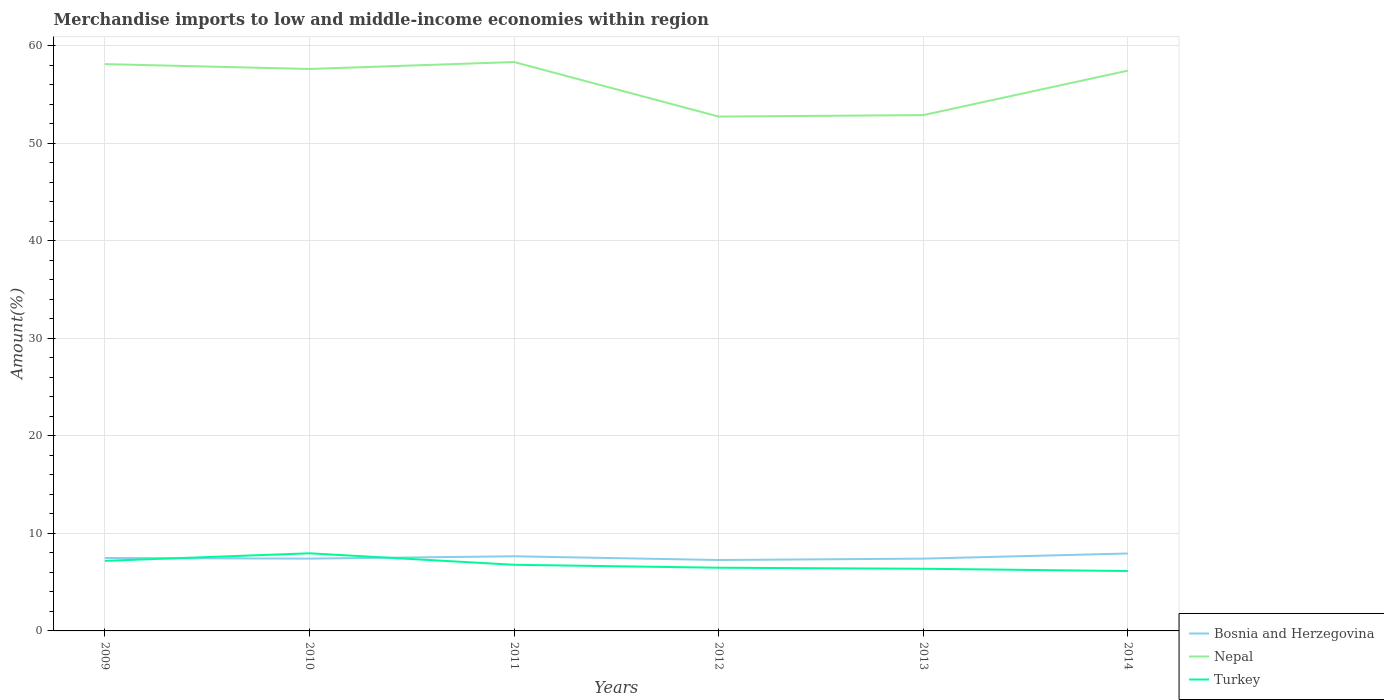How many different coloured lines are there?
Offer a terse response. 3. Is the number of lines equal to the number of legend labels?
Make the answer very short. Yes. Across all years, what is the maximum percentage of amount earned from merchandise imports in Turkey?
Provide a short and direct response. 6.14. What is the total percentage of amount earned from merchandise imports in Bosnia and Herzegovina in the graph?
Your answer should be very brief. -0.53. What is the difference between the highest and the second highest percentage of amount earned from merchandise imports in Turkey?
Your answer should be very brief. 1.82. Is the percentage of amount earned from merchandise imports in Bosnia and Herzegovina strictly greater than the percentage of amount earned from merchandise imports in Turkey over the years?
Provide a short and direct response. No. What is the difference between two consecutive major ticks on the Y-axis?
Your answer should be very brief. 10. Are the values on the major ticks of Y-axis written in scientific E-notation?
Your answer should be compact. No. Does the graph contain any zero values?
Your answer should be very brief. No. Does the graph contain grids?
Your answer should be compact. Yes. How are the legend labels stacked?
Provide a succinct answer. Vertical. What is the title of the graph?
Make the answer very short. Merchandise imports to low and middle-income economies within region. Does "Low & middle income" appear as one of the legend labels in the graph?
Ensure brevity in your answer.  No. What is the label or title of the Y-axis?
Offer a very short reply. Amount(%). What is the Amount(%) in Bosnia and Herzegovina in 2009?
Ensure brevity in your answer.  7.48. What is the Amount(%) of Nepal in 2009?
Ensure brevity in your answer.  58.12. What is the Amount(%) of Turkey in 2009?
Provide a succinct answer. 7.19. What is the Amount(%) of Bosnia and Herzegovina in 2010?
Give a very brief answer. 7.41. What is the Amount(%) in Nepal in 2010?
Keep it short and to the point. 57.62. What is the Amount(%) in Turkey in 2010?
Keep it short and to the point. 7.96. What is the Amount(%) in Bosnia and Herzegovina in 2011?
Give a very brief answer. 7.65. What is the Amount(%) of Nepal in 2011?
Your answer should be compact. 58.33. What is the Amount(%) in Turkey in 2011?
Ensure brevity in your answer.  6.78. What is the Amount(%) of Bosnia and Herzegovina in 2012?
Your response must be concise. 7.27. What is the Amount(%) in Nepal in 2012?
Keep it short and to the point. 52.74. What is the Amount(%) of Turkey in 2012?
Offer a very short reply. 6.48. What is the Amount(%) in Bosnia and Herzegovina in 2013?
Your answer should be compact. 7.41. What is the Amount(%) of Nepal in 2013?
Provide a succinct answer. 52.89. What is the Amount(%) of Turkey in 2013?
Provide a succinct answer. 6.37. What is the Amount(%) in Bosnia and Herzegovina in 2014?
Provide a succinct answer. 7.94. What is the Amount(%) of Nepal in 2014?
Your answer should be compact. 57.45. What is the Amount(%) in Turkey in 2014?
Provide a succinct answer. 6.14. Across all years, what is the maximum Amount(%) in Bosnia and Herzegovina?
Ensure brevity in your answer.  7.94. Across all years, what is the maximum Amount(%) in Nepal?
Provide a succinct answer. 58.33. Across all years, what is the maximum Amount(%) in Turkey?
Give a very brief answer. 7.96. Across all years, what is the minimum Amount(%) in Bosnia and Herzegovina?
Provide a short and direct response. 7.27. Across all years, what is the minimum Amount(%) in Nepal?
Give a very brief answer. 52.74. Across all years, what is the minimum Amount(%) in Turkey?
Provide a succinct answer. 6.14. What is the total Amount(%) of Bosnia and Herzegovina in the graph?
Keep it short and to the point. 45.17. What is the total Amount(%) of Nepal in the graph?
Give a very brief answer. 337.17. What is the total Amount(%) in Turkey in the graph?
Offer a very short reply. 40.92. What is the difference between the Amount(%) of Bosnia and Herzegovina in 2009 and that in 2010?
Offer a very short reply. 0.06. What is the difference between the Amount(%) of Nepal in 2009 and that in 2010?
Your answer should be compact. 0.5. What is the difference between the Amount(%) in Turkey in 2009 and that in 2010?
Offer a very short reply. -0.77. What is the difference between the Amount(%) of Bosnia and Herzegovina in 2009 and that in 2011?
Your answer should be very brief. -0.18. What is the difference between the Amount(%) of Nepal in 2009 and that in 2011?
Offer a terse response. -0.21. What is the difference between the Amount(%) in Turkey in 2009 and that in 2011?
Your answer should be very brief. 0.41. What is the difference between the Amount(%) of Bosnia and Herzegovina in 2009 and that in 2012?
Your answer should be very brief. 0.21. What is the difference between the Amount(%) of Nepal in 2009 and that in 2012?
Your answer should be compact. 5.38. What is the difference between the Amount(%) of Turkey in 2009 and that in 2012?
Make the answer very short. 0.71. What is the difference between the Amount(%) of Bosnia and Herzegovina in 2009 and that in 2013?
Keep it short and to the point. 0.06. What is the difference between the Amount(%) in Nepal in 2009 and that in 2013?
Give a very brief answer. 5.23. What is the difference between the Amount(%) of Turkey in 2009 and that in 2013?
Provide a short and direct response. 0.81. What is the difference between the Amount(%) of Bosnia and Herzegovina in 2009 and that in 2014?
Your response must be concise. -0.46. What is the difference between the Amount(%) of Nepal in 2009 and that in 2014?
Make the answer very short. 0.67. What is the difference between the Amount(%) in Turkey in 2009 and that in 2014?
Keep it short and to the point. 1.05. What is the difference between the Amount(%) in Bosnia and Herzegovina in 2010 and that in 2011?
Keep it short and to the point. -0.24. What is the difference between the Amount(%) in Nepal in 2010 and that in 2011?
Offer a very short reply. -0.71. What is the difference between the Amount(%) in Turkey in 2010 and that in 2011?
Offer a very short reply. 1.18. What is the difference between the Amount(%) of Bosnia and Herzegovina in 2010 and that in 2012?
Your answer should be compact. 0.14. What is the difference between the Amount(%) of Nepal in 2010 and that in 2012?
Provide a short and direct response. 4.88. What is the difference between the Amount(%) in Turkey in 2010 and that in 2012?
Provide a short and direct response. 1.48. What is the difference between the Amount(%) in Bosnia and Herzegovina in 2010 and that in 2013?
Offer a very short reply. -0. What is the difference between the Amount(%) of Nepal in 2010 and that in 2013?
Your answer should be very brief. 4.73. What is the difference between the Amount(%) in Turkey in 2010 and that in 2013?
Make the answer very short. 1.59. What is the difference between the Amount(%) in Bosnia and Herzegovina in 2010 and that in 2014?
Your response must be concise. -0.53. What is the difference between the Amount(%) of Nepal in 2010 and that in 2014?
Offer a very short reply. 0.17. What is the difference between the Amount(%) in Turkey in 2010 and that in 2014?
Your response must be concise. 1.82. What is the difference between the Amount(%) of Bosnia and Herzegovina in 2011 and that in 2012?
Offer a terse response. 0.38. What is the difference between the Amount(%) in Nepal in 2011 and that in 2012?
Ensure brevity in your answer.  5.59. What is the difference between the Amount(%) in Turkey in 2011 and that in 2012?
Your answer should be compact. 0.3. What is the difference between the Amount(%) of Bosnia and Herzegovina in 2011 and that in 2013?
Your response must be concise. 0.24. What is the difference between the Amount(%) in Nepal in 2011 and that in 2013?
Offer a terse response. 5.44. What is the difference between the Amount(%) in Turkey in 2011 and that in 2013?
Your answer should be compact. 0.41. What is the difference between the Amount(%) of Bosnia and Herzegovina in 2011 and that in 2014?
Give a very brief answer. -0.29. What is the difference between the Amount(%) of Nepal in 2011 and that in 2014?
Offer a very short reply. 0.88. What is the difference between the Amount(%) in Turkey in 2011 and that in 2014?
Your response must be concise. 0.64. What is the difference between the Amount(%) in Bosnia and Herzegovina in 2012 and that in 2013?
Provide a succinct answer. -0.14. What is the difference between the Amount(%) of Nepal in 2012 and that in 2013?
Make the answer very short. -0.15. What is the difference between the Amount(%) in Turkey in 2012 and that in 2013?
Provide a short and direct response. 0.11. What is the difference between the Amount(%) of Bosnia and Herzegovina in 2012 and that in 2014?
Provide a succinct answer. -0.67. What is the difference between the Amount(%) of Nepal in 2012 and that in 2014?
Your answer should be compact. -4.71. What is the difference between the Amount(%) of Turkey in 2012 and that in 2014?
Your response must be concise. 0.34. What is the difference between the Amount(%) in Bosnia and Herzegovina in 2013 and that in 2014?
Keep it short and to the point. -0.53. What is the difference between the Amount(%) in Nepal in 2013 and that in 2014?
Your response must be concise. -4.56. What is the difference between the Amount(%) of Turkey in 2013 and that in 2014?
Ensure brevity in your answer.  0.24. What is the difference between the Amount(%) in Bosnia and Herzegovina in 2009 and the Amount(%) in Nepal in 2010?
Offer a very short reply. -50.15. What is the difference between the Amount(%) of Bosnia and Herzegovina in 2009 and the Amount(%) of Turkey in 2010?
Your response must be concise. -0.48. What is the difference between the Amount(%) of Nepal in 2009 and the Amount(%) of Turkey in 2010?
Offer a terse response. 50.16. What is the difference between the Amount(%) in Bosnia and Herzegovina in 2009 and the Amount(%) in Nepal in 2011?
Offer a terse response. -50.86. What is the difference between the Amount(%) of Bosnia and Herzegovina in 2009 and the Amount(%) of Turkey in 2011?
Offer a very short reply. 0.7. What is the difference between the Amount(%) of Nepal in 2009 and the Amount(%) of Turkey in 2011?
Offer a terse response. 51.34. What is the difference between the Amount(%) in Bosnia and Herzegovina in 2009 and the Amount(%) in Nepal in 2012?
Make the answer very short. -45.26. What is the difference between the Amount(%) in Nepal in 2009 and the Amount(%) in Turkey in 2012?
Offer a very short reply. 51.64. What is the difference between the Amount(%) in Bosnia and Herzegovina in 2009 and the Amount(%) in Nepal in 2013?
Offer a terse response. -45.42. What is the difference between the Amount(%) in Bosnia and Herzegovina in 2009 and the Amount(%) in Turkey in 2013?
Offer a very short reply. 1.1. What is the difference between the Amount(%) of Nepal in 2009 and the Amount(%) of Turkey in 2013?
Your response must be concise. 51.75. What is the difference between the Amount(%) in Bosnia and Herzegovina in 2009 and the Amount(%) in Nepal in 2014?
Your response must be concise. -49.98. What is the difference between the Amount(%) of Bosnia and Herzegovina in 2009 and the Amount(%) of Turkey in 2014?
Your answer should be compact. 1.34. What is the difference between the Amount(%) of Nepal in 2009 and the Amount(%) of Turkey in 2014?
Your answer should be very brief. 51.98. What is the difference between the Amount(%) in Bosnia and Herzegovina in 2010 and the Amount(%) in Nepal in 2011?
Offer a terse response. -50.92. What is the difference between the Amount(%) of Bosnia and Herzegovina in 2010 and the Amount(%) of Turkey in 2011?
Ensure brevity in your answer.  0.63. What is the difference between the Amount(%) of Nepal in 2010 and the Amount(%) of Turkey in 2011?
Your answer should be very brief. 50.84. What is the difference between the Amount(%) of Bosnia and Herzegovina in 2010 and the Amount(%) of Nepal in 2012?
Your answer should be compact. -45.33. What is the difference between the Amount(%) in Bosnia and Herzegovina in 2010 and the Amount(%) in Turkey in 2012?
Give a very brief answer. 0.93. What is the difference between the Amount(%) of Nepal in 2010 and the Amount(%) of Turkey in 2012?
Offer a terse response. 51.14. What is the difference between the Amount(%) of Bosnia and Herzegovina in 2010 and the Amount(%) of Nepal in 2013?
Keep it short and to the point. -45.48. What is the difference between the Amount(%) of Bosnia and Herzegovina in 2010 and the Amount(%) of Turkey in 2013?
Ensure brevity in your answer.  1.04. What is the difference between the Amount(%) in Nepal in 2010 and the Amount(%) in Turkey in 2013?
Provide a short and direct response. 51.25. What is the difference between the Amount(%) of Bosnia and Herzegovina in 2010 and the Amount(%) of Nepal in 2014?
Offer a terse response. -50.04. What is the difference between the Amount(%) of Bosnia and Herzegovina in 2010 and the Amount(%) of Turkey in 2014?
Your response must be concise. 1.27. What is the difference between the Amount(%) of Nepal in 2010 and the Amount(%) of Turkey in 2014?
Your answer should be compact. 51.48. What is the difference between the Amount(%) in Bosnia and Herzegovina in 2011 and the Amount(%) in Nepal in 2012?
Keep it short and to the point. -45.09. What is the difference between the Amount(%) of Bosnia and Herzegovina in 2011 and the Amount(%) of Turkey in 2012?
Keep it short and to the point. 1.17. What is the difference between the Amount(%) in Nepal in 2011 and the Amount(%) in Turkey in 2012?
Keep it short and to the point. 51.85. What is the difference between the Amount(%) in Bosnia and Herzegovina in 2011 and the Amount(%) in Nepal in 2013?
Offer a very short reply. -45.24. What is the difference between the Amount(%) of Bosnia and Herzegovina in 2011 and the Amount(%) of Turkey in 2013?
Offer a terse response. 1.28. What is the difference between the Amount(%) of Nepal in 2011 and the Amount(%) of Turkey in 2013?
Your answer should be compact. 51.96. What is the difference between the Amount(%) of Bosnia and Herzegovina in 2011 and the Amount(%) of Nepal in 2014?
Your answer should be very brief. -49.8. What is the difference between the Amount(%) of Bosnia and Herzegovina in 2011 and the Amount(%) of Turkey in 2014?
Your answer should be very brief. 1.51. What is the difference between the Amount(%) in Nepal in 2011 and the Amount(%) in Turkey in 2014?
Give a very brief answer. 52.2. What is the difference between the Amount(%) in Bosnia and Herzegovina in 2012 and the Amount(%) in Nepal in 2013?
Your response must be concise. -45.62. What is the difference between the Amount(%) of Bosnia and Herzegovina in 2012 and the Amount(%) of Turkey in 2013?
Your response must be concise. 0.9. What is the difference between the Amount(%) in Nepal in 2012 and the Amount(%) in Turkey in 2013?
Provide a short and direct response. 46.37. What is the difference between the Amount(%) of Bosnia and Herzegovina in 2012 and the Amount(%) of Nepal in 2014?
Your answer should be very brief. -50.18. What is the difference between the Amount(%) in Bosnia and Herzegovina in 2012 and the Amount(%) in Turkey in 2014?
Provide a short and direct response. 1.13. What is the difference between the Amount(%) in Nepal in 2012 and the Amount(%) in Turkey in 2014?
Offer a very short reply. 46.6. What is the difference between the Amount(%) in Bosnia and Herzegovina in 2013 and the Amount(%) in Nepal in 2014?
Ensure brevity in your answer.  -50.04. What is the difference between the Amount(%) in Bosnia and Herzegovina in 2013 and the Amount(%) in Turkey in 2014?
Provide a succinct answer. 1.28. What is the difference between the Amount(%) of Nepal in 2013 and the Amount(%) of Turkey in 2014?
Your answer should be very brief. 46.75. What is the average Amount(%) of Bosnia and Herzegovina per year?
Ensure brevity in your answer.  7.53. What is the average Amount(%) in Nepal per year?
Your answer should be compact. 56.19. What is the average Amount(%) of Turkey per year?
Keep it short and to the point. 6.82. In the year 2009, what is the difference between the Amount(%) in Bosnia and Herzegovina and Amount(%) in Nepal?
Provide a succinct answer. -50.64. In the year 2009, what is the difference between the Amount(%) of Bosnia and Herzegovina and Amount(%) of Turkey?
Provide a short and direct response. 0.29. In the year 2009, what is the difference between the Amount(%) of Nepal and Amount(%) of Turkey?
Your answer should be very brief. 50.93. In the year 2010, what is the difference between the Amount(%) in Bosnia and Herzegovina and Amount(%) in Nepal?
Give a very brief answer. -50.21. In the year 2010, what is the difference between the Amount(%) in Bosnia and Herzegovina and Amount(%) in Turkey?
Ensure brevity in your answer.  -0.55. In the year 2010, what is the difference between the Amount(%) of Nepal and Amount(%) of Turkey?
Provide a succinct answer. 49.66. In the year 2011, what is the difference between the Amount(%) of Bosnia and Herzegovina and Amount(%) of Nepal?
Ensure brevity in your answer.  -50.68. In the year 2011, what is the difference between the Amount(%) in Bosnia and Herzegovina and Amount(%) in Turkey?
Make the answer very short. 0.87. In the year 2011, what is the difference between the Amount(%) of Nepal and Amount(%) of Turkey?
Offer a very short reply. 51.55. In the year 2012, what is the difference between the Amount(%) of Bosnia and Herzegovina and Amount(%) of Nepal?
Offer a terse response. -45.47. In the year 2012, what is the difference between the Amount(%) of Bosnia and Herzegovina and Amount(%) of Turkey?
Give a very brief answer. 0.79. In the year 2012, what is the difference between the Amount(%) of Nepal and Amount(%) of Turkey?
Make the answer very short. 46.26. In the year 2013, what is the difference between the Amount(%) of Bosnia and Herzegovina and Amount(%) of Nepal?
Provide a short and direct response. -45.48. In the year 2013, what is the difference between the Amount(%) in Bosnia and Herzegovina and Amount(%) in Turkey?
Your answer should be compact. 1.04. In the year 2013, what is the difference between the Amount(%) of Nepal and Amount(%) of Turkey?
Provide a short and direct response. 46.52. In the year 2014, what is the difference between the Amount(%) of Bosnia and Herzegovina and Amount(%) of Nepal?
Your answer should be compact. -49.51. In the year 2014, what is the difference between the Amount(%) in Bosnia and Herzegovina and Amount(%) in Turkey?
Offer a very short reply. 1.8. In the year 2014, what is the difference between the Amount(%) of Nepal and Amount(%) of Turkey?
Provide a short and direct response. 51.31. What is the ratio of the Amount(%) of Bosnia and Herzegovina in 2009 to that in 2010?
Keep it short and to the point. 1.01. What is the ratio of the Amount(%) of Nepal in 2009 to that in 2010?
Your response must be concise. 1.01. What is the ratio of the Amount(%) in Turkey in 2009 to that in 2010?
Make the answer very short. 0.9. What is the ratio of the Amount(%) in Bosnia and Herzegovina in 2009 to that in 2011?
Keep it short and to the point. 0.98. What is the ratio of the Amount(%) in Nepal in 2009 to that in 2011?
Keep it short and to the point. 1. What is the ratio of the Amount(%) of Turkey in 2009 to that in 2011?
Ensure brevity in your answer.  1.06. What is the ratio of the Amount(%) in Bosnia and Herzegovina in 2009 to that in 2012?
Offer a terse response. 1.03. What is the ratio of the Amount(%) in Nepal in 2009 to that in 2012?
Keep it short and to the point. 1.1. What is the ratio of the Amount(%) in Turkey in 2009 to that in 2012?
Make the answer very short. 1.11. What is the ratio of the Amount(%) in Bosnia and Herzegovina in 2009 to that in 2013?
Offer a very short reply. 1.01. What is the ratio of the Amount(%) of Nepal in 2009 to that in 2013?
Your answer should be very brief. 1.1. What is the ratio of the Amount(%) in Turkey in 2009 to that in 2013?
Make the answer very short. 1.13. What is the ratio of the Amount(%) of Bosnia and Herzegovina in 2009 to that in 2014?
Offer a very short reply. 0.94. What is the ratio of the Amount(%) in Nepal in 2009 to that in 2014?
Offer a very short reply. 1.01. What is the ratio of the Amount(%) of Turkey in 2009 to that in 2014?
Your answer should be very brief. 1.17. What is the ratio of the Amount(%) of Bosnia and Herzegovina in 2010 to that in 2011?
Keep it short and to the point. 0.97. What is the ratio of the Amount(%) of Turkey in 2010 to that in 2011?
Your answer should be very brief. 1.17. What is the ratio of the Amount(%) in Bosnia and Herzegovina in 2010 to that in 2012?
Give a very brief answer. 1.02. What is the ratio of the Amount(%) in Nepal in 2010 to that in 2012?
Your response must be concise. 1.09. What is the ratio of the Amount(%) of Turkey in 2010 to that in 2012?
Your response must be concise. 1.23. What is the ratio of the Amount(%) in Bosnia and Herzegovina in 2010 to that in 2013?
Keep it short and to the point. 1. What is the ratio of the Amount(%) of Nepal in 2010 to that in 2013?
Offer a terse response. 1.09. What is the ratio of the Amount(%) in Turkey in 2010 to that in 2013?
Offer a terse response. 1.25. What is the ratio of the Amount(%) of Bosnia and Herzegovina in 2010 to that in 2014?
Provide a succinct answer. 0.93. What is the ratio of the Amount(%) in Turkey in 2010 to that in 2014?
Offer a terse response. 1.3. What is the ratio of the Amount(%) of Bosnia and Herzegovina in 2011 to that in 2012?
Provide a succinct answer. 1.05. What is the ratio of the Amount(%) in Nepal in 2011 to that in 2012?
Provide a succinct answer. 1.11. What is the ratio of the Amount(%) of Turkey in 2011 to that in 2012?
Offer a very short reply. 1.05. What is the ratio of the Amount(%) of Bosnia and Herzegovina in 2011 to that in 2013?
Your response must be concise. 1.03. What is the ratio of the Amount(%) in Nepal in 2011 to that in 2013?
Provide a short and direct response. 1.1. What is the ratio of the Amount(%) of Turkey in 2011 to that in 2013?
Provide a succinct answer. 1.06. What is the ratio of the Amount(%) in Nepal in 2011 to that in 2014?
Your answer should be very brief. 1.02. What is the ratio of the Amount(%) in Turkey in 2011 to that in 2014?
Give a very brief answer. 1.1. What is the ratio of the Amount(%) of Bosnia and Herzegovina in 2012 to that in 2013?
Keep it short and to the point. 0.98. What is the ratio of the Amount(%) in Turkey in 2012 to that in 2013?
Give a very brief answer. 1.02. What is the ratio of the Amount(%) in Bosnia and Herzegovina in 2012 to that in 2014?
Make the answer very short. 0.92. What is the ratio of the Amount(%) of Nepal in 2012 to that in 2014?
Give a very brief answer. 0.92. What is the ratio of the Amount(%) in Turkey in 2012 to that in 2014?
Ensure brevity in your answer.  1.06. What is the ratio of the Amount(%) in Bosnia and Herzegovina in 2013 to that in 2014?
Your answer should be very brief. 0.93. What is the ratio of the Amount(%) in Nepal in 2013 to that in 2014?
Provide a short and direct response. 0.92. What is the ratio of the Amount(%) of Turkey in 2013 to that in 2014?
Offer a terse response. 1.04. What is the difference between the highest and the second highest Amount(%) in Bosnia and Herzegovina?
Your response must be concise. 0.29. What is the difference between the highest and the second highest Amount(%) of Nepal?
Your response must be concise. 0.21. What is the difference between the highest and the second highest Amount(%) in Turkey?
Provide a succinct answer. 0.77. What is the difference between the highest and the lowest Amount(%) in Bosnia and Herzegovina?
Give a very brief answer. 0.67. What is the difference between the highest and the lowest Amount(%) of Nepal?
Your response must be concise. 5.59. What is the difference between the highest and the lowest Amount(%) of Turkey?
Offer a terse response. 1.82. 